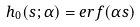Convert formula to latex. <formula><loc_0><loc_0><loc_500><loc_500>h _ { 0 } ( s ; \alpha ) = e r f ( \alpha s )</formula> 